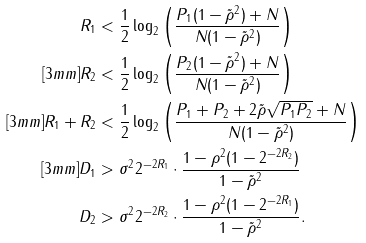<formula> <loc_0><loc_0><loc_500><loc_500>R _ { 1 } & < \frac { 1 } { 2 } \log _ { 2 } \left ( \frac { P _ { 1 } ( 1 - \tilde { \rho } ^ { 2 } ) + N } { N ( 1 - \tilde { \rho } ^ { 2 } ) } \right ) \\ [ 3 m m ] R _ { 2 } & < \frac { 1 } { 2 } \log _ { 2 } \left ( \frac { P _ { 2 } ( 1 - \tilde { \rho } ^ { 2 } ) + N } { N ( 1 - \tilde { \rho } ^ { 2 } ) } \right ) \\ [ 3 m m ] R _ { 1 } + R _ { 2 } & < \frac { 1 } { 2 } \log _ { 2 } \left ( \frac { P _ { 1 } + P _ { 2 } + 2 \tilde { \rho } \sqrt { P _ { 1 } P _ { 2 } } + N } { N ( 1 - \tilde { \rho } ^ { 2 } ) } \right ) \\ [ 3 m m ] D _ { 1 } & > \sigma ^ { 2 } 2 ^ { - 2 R _ { 1 } } \cdot \frac { 1 - \rho ^ { 2 } ( 1 - 2 ^ { - 2 R _ { 2 } } ) } { 1 - \tilde { \rho } ^ { 2 } } \\ D _ { 2 } & > \sigma ^ { 2 } 2 ^ { - 2 R _ { 2 } } \cdot \frac { 1 - \rho ^ { 2 } ( 1 - 2 ^ { - 2 R _ { 1 } } ) } { 1 - \tilde { \rho } ^ { 2 } } .</formula> 